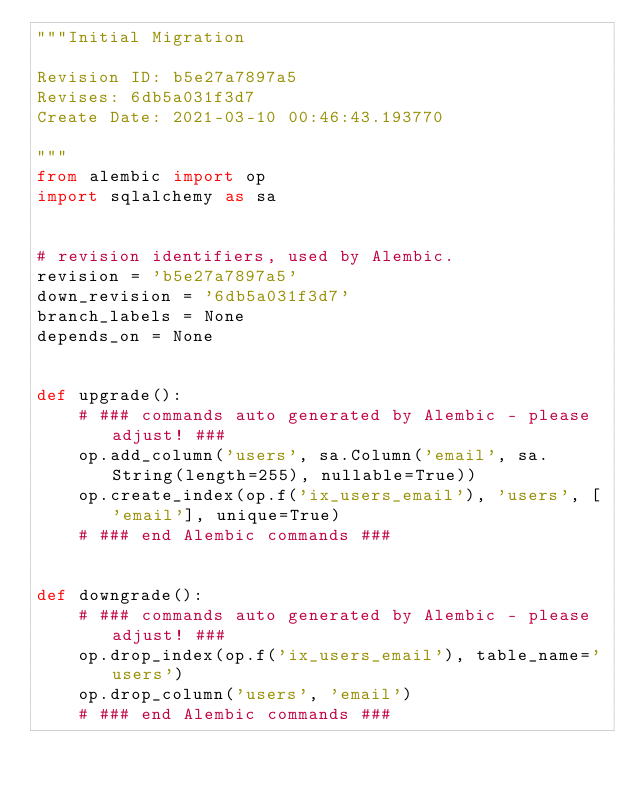<code> <loc_0><loc_0><loc_500><loc_500><_Python_>"""Initial Migration

Revision ID: b5e27a7897a5
Revises: 6db5a031f3d7
Create Date: 2021-03-10 00:46:43.193770

"""
from alembic import op
import sqlalchemy as sa


# revision identifiers, used by Alembic.
revision = 'b5e27a7897a5'
down_revision = '6db5a031f3d7'
branch_labels = None
depends_on = None


def upgrade():
    # ### commands auto generated by Alembic - please adjust! ###
    op.add_column('users', sa.Column('email', sa.String(length=255), nullable=True))
    op.create_index(op.f('ix_users_email'), 'users', ['email'], unique=True)
    # ### end Alembic commands ###


def downgrade():
    # ### commands auto generated by Alembic - please adjust! ###
    op.drop_index(op.f('ix_users_email'), table_name='users')
    op.drop_column('users', 'email')
    # ### end Alembic commands ###
</code> 